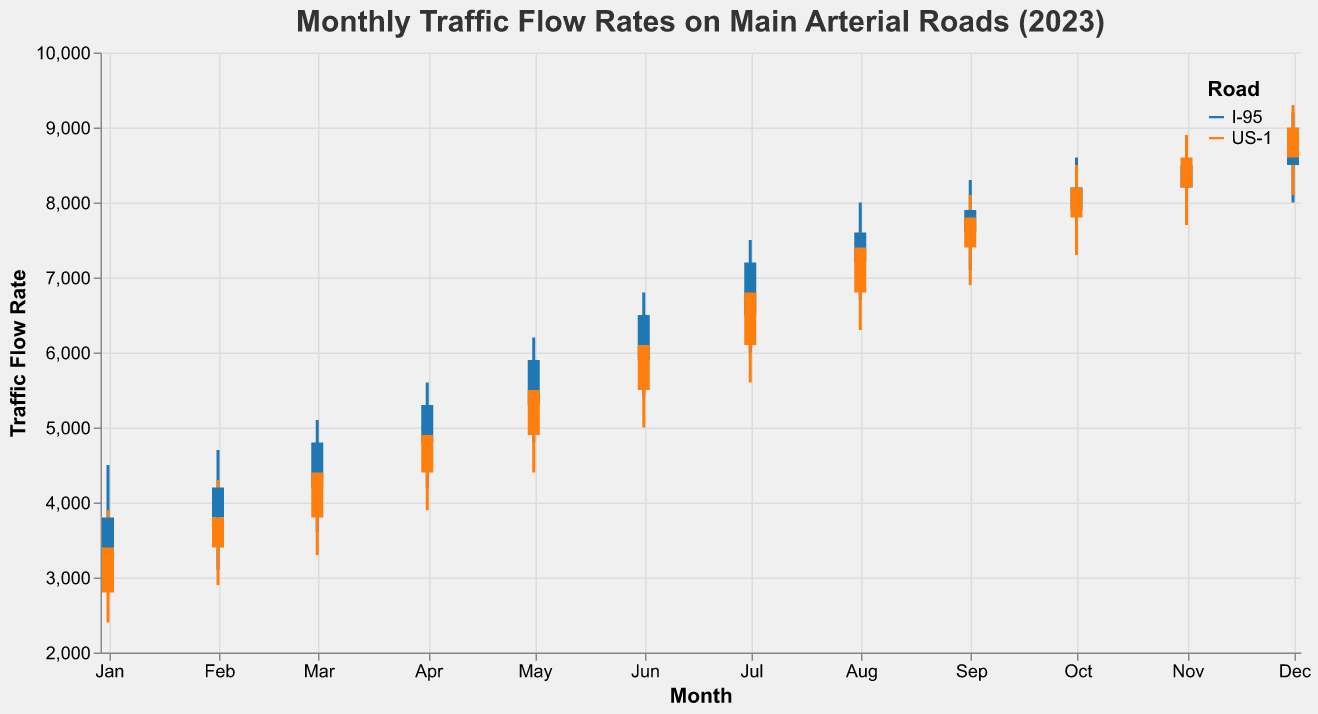What's the title of the figure? The title is located at the top of the figure and describes what the figure is about.
Answer: Monthly Traffic Flow Rates on Main Arterial Roads (2023) Which road had the highest traffic flow in December 2023? In December 2023, US-1 had the highest traffic flow rate, reaching a high of 9300, compared to I-95 which reached a high of 9200.
Answer: US-1 What was the lowest traffic flow rate for I-95 in 2023? The lowest traffic flow rate for I-95 in 2023 was in January, when the low was recorded at 2800.
Answer: 2800 Compare the opening traffic flow rates for US-1 and I-95 in July 2023; which one was higher? In July 2023, the opening traffic flow rate for US-1 was 6100, whereas for I-95 it was 6500. Therefore, I-95 had a higher opening traffic flow rate.
Answer: I-95 What is the overall trend in traffic flow rates for I-95 throughout the year 2023? Observing the data for I-95 from January to December, the traffic flow rates show an increasing trend throughout the year. This can be seen by the gradual increase in high, low, open, and close values from January to December.
Answer: Increasing trend When did the US-1 roadway reach its highest closing traffic flow rate? US-1 reached its highest closing traffic flow rate in December 2023 at 9000.
Answer: December 2023 What is the range of traffic flow rates for I-95 in August 2023? In August 2023, the traffic flow for I-95 ranged from a low of 6700 to a high of 8000.
Answer: 6700 to 8000 How does the traffic flow for US-1 in March compare to the traffic flow for I-95 in March? In March for US-1, the open is 3800, high is 4700, low is 3300, and close is 4400. For I-95, the open is 4200, high is 5100, low is 3600, and close is 4800. Therefore, I-95 has higher values in all categories compared to US-1.
Answer: I-95 has higher values What is the average high traffic flow rate for US-1 in the first quarter (January to March) of 2023? The high rates for US-1 in January, February, and March are 3900, 4300, and 4700 respectively. Their average is calculated as (3900 + 4300 + 4700) / 3 = 4300.
Answer: 4300 In which month did I-95 see its lowest closing traffic flow rate in 2023, and what was the value? The lowest closing traffic flow rate for I-95 in 2023 was recorded in January, where the closing value was 3800.
Answer: January, 3800 